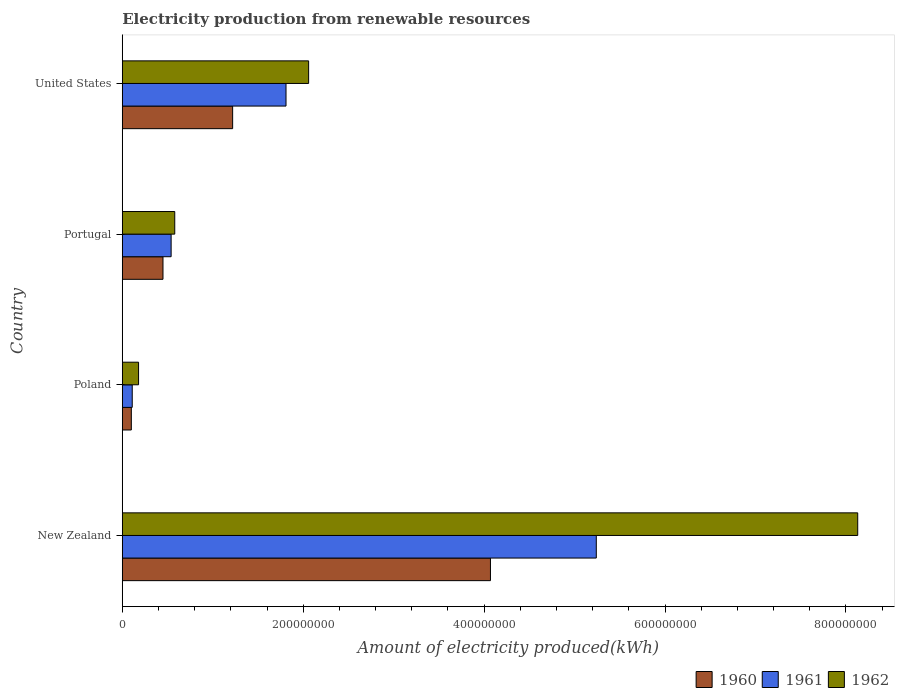How many different coloured bars are there?
Ensure brevity in your answer.  3. What is the label of the 4th group of bars from the top?
Make the answer very short. New Zealand. In how many cases, is the number of bars for a given country not equal to the number of legend labels?
Give a very brief answer. 0. What is the amount of electricity produced in 1961 in Poland?
Offer a very short reply. 1.10e+07. Across all countries, what is the maximum amount of electricity produced in 1960?
Make the answer very short. 4.07e+08. In which country was the amount of electricity produced in 1962 maximum?
Keep it short and to the point. New Zealand. In which country was the amount of electricity produced in 1961 minimum?
Give a very brief answer. Poland. What is the total amount of electricity produced in 1962 in the graph?
Your answer should be compact. 1.10e+09. What is the difference between the amount of electricity produced in 1961 in Portugal and that in United States?
Ensure brevity in your answer.  -1.27e+08. What is the difference between the amount of electricity produced in 1962 in New Zealand and the amount of electricity produced in 1960 in United States?
Make the answer very short. 6.91e+08. What is the average amount of electricity produced in 1960 per country?
Provide a succinct answer. 1.46e+08. What is the difference between the amount of electricity produced in 1961 and amount of electricity produced in 1960 in New Zealand?
Provide a succinct answer. 1.17e+08. What is the ratio of the amount of electricity produced in 1961 in New Zealand to that in Portugal?
Offer a terse response. 9.7. Is the amount of electricity produced in 1962 in Poland less than that in United States?
Your response must be concise. Yes. What is the difference between the highest and the second highest amount of electricity produced in 1962?
Make the answer very short. 6.07e+08. What is the difference between the highest and the lowest amount of electricity produced in 1960?
Make the answer very short. 3.97e+08. Is the sum of the amount of electricity produced in 1962 in Portugal and United States greater than the maximum amount of electricity produced in 1961 across all countries?
Your answer should be very brief. No. What does the 3rd bar from the top in Portugal represents?
Make the answer very short. 1960. Is it the case that in every country, the sum of the amount of electricity produced in 1960 and amount of electricity produced in 1962 is greater than the amount of electricity produced in 1961?
Your response must be concise. Yes. Are all the bars in the graph horizontal?
Keep it short and to the point. Yes. What is the difference between two consecutive major ticks on the X-axis?
Make the answer very short. 2.00e+08. Does the graph contain any zero values?
Offer a terse response. No. How many legend labels are there?
Ensure brevity in your answer.  3. How are the legend labels stacked?
Your response must be concise. Horizontal. What is the title of the graph?
Provide a short and direct response. Electricity production from renewable resources. What is the label or title of the X-axis?
Ensure brevity in your answer.  Amount of electricity produced(kWh). What is the label or title of the Y-axis?
Ensure brevity in your answer.  Country. What is the Amount of electricity produced(kWh) of 1960 in New Zealand?
Ensure brevity in your answer.  4.07e+08. What is the Amount of electricity produced(kWh) of 1961 in New Zealand?
Your response must be concise. 5.24e+08. What is the Amount of electricity produced(kWh) in 1962 in New Zealand?
Provide a short and direct response. 8.13e+08. What is the Amount of electricity produced(kWh) of 1961 in Poland?
Provide a succinct answer. 1.10e+07. What is the Amount of electricity produced(kWh) in 1962 in Poland?
Your response must be concise. 1.80e+07. What is the Amount of electricity produced(kWh) in 1960 in Portugal?
Ensure brevity in your answer.  4.50e+07. What is the Amount of electricity produced(kWh) of 1961 in Portugal?
Offer a terse response. 5.40e+07. What is the Amount of electricity produced(kWh) in 1962 in Portugal?
Your answer should be compact. 5.80e+07. What is the Amount of electricity produced(kWh) in 1960 in United States?
Make the answer very short. 1.22e+08. What is the Amount of electricity produced(kWh) in 1961 in United States?
Offer a terse response. 1.81e+08. What is the Amount of electricity produced(kWh) in 1962 in United States?
Offer a terse response. 2.06e+08. Across all countries, what is the maximum Amount of electricity produced(kWh) of 1960?
Your answer should be very brief. 4.07e+08. Across all countries, what is the maximum Amount of electricity produced(kWh) of 1961?
Provide a short and direct response. 5.24e+08. Across all countries, what is the maximum Amount of electricity produced(kWh) in 1962?
Provide a succinct answer. 8.13e+08. Across all countries, what is the minimum Amount of electricity produced(kWh) of 1960?
Offer a very short reply. 1.00e+07. Across all countries, what is the minimum Amount of electricity produced(kWh) of 1961?
Your response must be concise. 1.10e+07. Across all countries, what is the minimum Amount of electricity produced(kWh) in 1962?
Your response must be concise. 1.80e+07. What is the total Amount of electricity produced(kWh) of 1960 in the graph?
Your answer should be compact. 5.84e+08. What is the total Amount of electricity produced(kWh) of 1961 in the graph?
Keep it short and to the point. 7.70e+08. What is the total Amount of electricity produced(kWh) in 1962 in the graph?
Give a very brief answer. 1.10e+09. What is the difference between the Amount of electricity produced(kWh) in 1960 in New Zealand and that in Poland?
Offer a very short reply. 3.97e+08. What is the difference between the Amount of electricity produced(kWh) in 1961 in New Zealand and that in Poland?
Your answer should be compact. 5.13e+08. What is the difference between the Amount of electricity produced(kWh) in 1962 in New Zealand and that in Poland?
Your answer should be very brief. 7.95e+08. What is the difference between the Amount of electricity produced(kWh) of 1960 in New Zealand and that in Portugal?
Your response must be concise. 3.62e+08. What is the difference between the Amount of electricity produced(kWh) of 1961 in New Zealand and that in Portugal?
Keep it short and to the point. 4.70e+08. What is the difference between the Amount of electricity produced(kWh) in 1962 in New Zealand and that in Portugal?
Provide a succinct answer. 7.55e+08. What is the difference between the Amount of electricity produced(kWh) of 1960 in New Zealand and that in United States?
Ensure brevity in your answer.  2.85e+08. What is the difference between the Amount of electricity produced(kWh) in 1961 in New Zealand and that in United States?
Offer a very short reply. 3.43e+08. What is the difference between the Amount of electricity produced(kWh) of 1962 in New Zealand and that in United States?
Make the answer very short. 6.07e+08. What is the difference between the Amount of electricity produced(kWh) of 1960 in Poland and that in Portugal?
Ensure brevity in your answer.  -3.50e+07. What is the difference between the Amount of electricity produced(kWh) of 1961 in Poland and that in Portugal?
Provide a short and direct response. -4.30e+07. What is the difference between the Amount of electricity produced(kWh) of 1962 in Poland and that in Portugal?
Offer a terse response. -4.00e+07. What is the difference between the Amount of electricity produced(kWh) in 1960 in Poland and that in United States?
Keep it short and to the point. -1.12e+08. What is the difference between the Amount of electricity produced(kWh) in 1961 in Poland and that in United States?
Offer a terse response. -1.70e+08. What is the difference between the Amount of electricity produced(kWh) in 1962 in Poland and that in United States?
Your answer should be very brief. -1.88e+08. What is the difference between the Amount of electricity produced(kWh) of 1960 in Portugal and that in United States?
Provide a short and direct response. -7.70e+07. What is the difference between the Amount of electricity produced(kWh) in 1961 in Portugal and that in United States?
Make the answer very short. -1.27e+08. What is the difference between the Amount of electricity produced(kWh) of 1962 in Portugal and that in United States?
Keep it short and to the point. -1.48e+08. What is the difference between the Amount of electricity produced(kWh) in 1960 in New Zealand and the Amount of electricity produced(kWh) in 1961 in Poland?
Your answer should be very brief. 3.96e+08. What is the difference between the Amount of electricity produced(kWh) of 1960 in New Zealand and the Amount of electricity produced(kWh) of 1962 in Poland?
Offer a terse response. 3.89e+08. What is the difference between the Amount of electricity produced(kWh) in 1961 in New Zealand and the Amount of electricity produced(kWh) in 1962 in Poland?
Give a very brief answer. 5.06e+08. What is the difference between the Amount of electricity produced(kWh) of 1960 in New Zealand and the Amount of electricity produced(kWh) of 1961 in Portugal?
Provide a short and direct response. 3.53e+08. What is the difference between the Amount of electricity produced(kWh) of 1960 in New Zealand and the Amount of electricity produced(kWh) of 1962 in Portugal?
Your answer should be compact. 3.49e+08. What is the difference between the Amount of electricity produced(kWh) of 1961 in New Zealand and the Amount of electricity produced(kWh) of 1962 in Portugal?
Offer a very short reply. 4.66e+08. What is the difference between the Amount of electricity produced(kWh) of 1960 in New Zealand and the Amount of electricity produced(kWh) of 1961 in United States?
Keep it short and to the point. 2.26e+08. What is the difference between the Amount of electricity produced(kWh) in 1960 in New Zealand and the Amount of electricity produced(kWh) in 1962 in United States?
Keep it short and to the point. 2.01e+08. What is the difference between the Amount of electricity produced(kWh) in 1961 in New Zealand and the Amount of electricity produced(kWh) in 1962 in United States?
Keep it short and to the point. 3.18e+08. What is the difference between the Amount of electricity produced(kWh) of 1960 in Poland and the Amount of electricity produced(kWh) of 1961 in Portugal?
Make the answer very short. -4.40e+07. What is the difference between the Amount of electricity produced(kWh) of 1960 in Poland and the Amount of electricity produced(kWh) of 1962 in Portugal?
Offer a very short reply. -4.80e+07. What is the difference between the Amount of electricity produced(kWh) in 1961 in Poland and the Amount of electricity produced(kWh) in 1962 in Portugal?
Give a very brief answer. -4.70e+07. What is the difference between the Amount of electricity produced(kWh) in 1960 in Poland and the Amount of electricity produced(kWh) in 1961 in United States?
Your answer should be very brief. -1.71e+08. What is the difference between the Amount of electricity produced(kWh) of 1960 in Poland and the Amount of electricity produced(kWh) of 1962 in United States?
Offer a very short reply. -1.96e+08. What is the difference between the Amount of electricity produced(kWh) in 1961 in Poland and the Amount of electricity produced(kWh) in 1962 in United States?
Your answer should be compact. -1.95e+08. What is the difference between the Amount of electricity produced(kWh) of 1960 in Portugal and the Amount of electricity produced(kWh) of 1961 in United States?
Provide a succinct answer. -1.36e+08. What is the difference between the Amount of electricity produced(kWh) of 1960 in Portugal and the Amount of electricity produced(kWh) of 1962 in United States?
Provide a succinct answer. -1.61e+08. What is the difference between the Amount of electricity produced(kWh) of 1961 in Portugal and the Amount of electricity produced(kWh) of 1962 in United States?
Make the answer very short. -1.52e+08. What is the average Amount of electricity produced(kWh) of 1960 per country?
Provide a short and direct response. 1.46e+08. What is the average Amount of electricity produced(kWh) in 1961 per country?
Keep it short and to the point. 1.92e+08. What is the average Amount of electricity produced(kWh) of 1962 per country?
Make the answer very short. 2.74e+08. What is the difference between the Amount of electricity produced(kWh) in 1960 and Amount of electricity produced(kWh) in 1961 in New Zealand?
Make the answer very short. -1.17e+08. What is the difference between the Amount of electricity produced(kWh) in 1960 and Amount of electricity produced(kWh) in 1962 in New Zealand?
Keep it short and to the point. -4.06e+08. What is the difference between the Amount of electricity produced(kWh) in 1961 and Amount of electricity produced(kWh) in 1962 in New Zealand?
Keep it short and to the point. -2.89e+08. What is the difference between the Amount of electricity produced(kWh) of 1960 and Amount of electricity produced(kWh) of 1962 in Poland?
Provide a short and direct response. -8.00e+06. What is the difference between the Amount of electricity produced(kWh) of 1961 and Amount of electricity produced(kWh) of 1962 in Poland?
Give a very brief answer. -7.00e+06. What is the difference between the Amount of electricity produced(kWh) in 1960 and Amount of electricity produced(kWh) in 1961 in Portugal?
Keep it short and to the point. -9.00e+06. What is the difference between the Amount of electricity produced(kWh) in 1960 and Amount of electricity produced(kWh) in 1962 in Portugal?
Provide a short and direct response. -1.30e+07. What is the difference between the Amount of electricity produced(kWh) of 1960 and Amount of electricity produced(kWh) of 1961 in United States?
Offer a very short reply. -5.90e+07. What is the difference between the Amount of electricity produced(kWh) of 1960 and Amount of electricity produced(kWh) of 1962 in United States?
Offer a very short reply. -8.40e+07. What is the difference between the Amount of electricity produced(kWh) in 1961 and Amount of electricity produced(kWh) in 1962 in United States?
Your response must be concise. -2.50e+07. What is the ratio of the Amount of electricity produced(kWh) of 1960 in New Zealand to that in Poland?
Your answer should be very brief. 40.7. What is the ratio of the Amount of electricity produced(kWh) of 1961 in New Zealand to that in Poland?
Provide a short and direct response. 47.64. What is the ratio of the Amount of electricity produced(kWh) in 1962 in New Zealand to that in Poland?
Provide a short and direct response. 45.17. What is the ratio of the Amount of electricity produced(kWh) in 1960 in New Zealand to that in Portugal?
Your answer should be compact. 9.04. What is the ratio of the Amount of electricity produced(kWh) of 1961 in New Zealand to that in Portugal?
Offer a very short reply. 9.7. What is the ratio of the Amount of electricity produced(kWh) of 1962 in New Zealand to that in Portugal?
Give a very brief answer. 14.02. What is the ratio of the Amount of electricity produced(kWh) of 1960 in New Zealand to that in United States?
Your response must be concise. 3.34. What is the ratio of the Amount of electricity produced(kWh) of 1961 in New Zealand to that in United States?
Provide a succinct answer. 2.9. What is the ratio of the Amount of electricity produced(kWh) in 1962 in New Zealand to that in United States?
Offer a terse response. 3.95. What is the ratio of the Amount of electricity produced(kWh) of 1960 in Poland to that in Portugal?
Make the answer very short. 0.22. What is the ratio of the Amount of electricity produced(kWh) in 1961 in Poland to that in Portugal?
Your response must be concise. 0.2. What is the ratio of the Amount of electricity produced(kWh) in 1962 in Poland to that in Portugal?
Ensure brevity in your answer.  0.31. What is the ratio of the Amount of electricity produced(kWh) in 1960 in Poland to that in United States?
Make the answer very short. 0.08. What is the ratio of the Amount of electricity produced(kWh) in 1961 in Poland to that in United States?
Your response must be concise. 0.06. What is the ratio of the Amount of electricity produced(kWh) of 1962 in Poland to that in United States?
Offer a very short reply. 0.09. What is the ratio of the Amount of electricity produced(kWh) of 1960 in Portugal to that in United States?
Ensure brevity in your answer.  0.37. What is the ratio of the Amount of electricity produced(kWh) in 1961 in Portugal to that in United States?
Make the answer very short. 0.3. What is the ratio of the Amount of electricity produced(kWh) in 1962 in Portugal to that in United States?
Your answer should be very brief. 0.28. What is the difference between the highest and the second highest Amount of electricity produced(kWh) of 1960?
Keep it short and to the point. 2.85e+08. What is the difference between the highest and the second highest Amount of electricity produced(kWh) of 1961?
Keep it short and to the point. 3.43e+08. What is the difference between the highest and the second highest Amount of electricity produced(kWh) of 1962?
Give a very brief answer. 6.07e+08. What is the difference between the highest and the lowest Amount of electricity produced(kWh) in 1960?
Your response must be concise. 3.97e+08. What is the difference between the highest and the lowest Amount of electricity produced(kWh) in 1961?
Offer a very short reply. 5.13e+08. What is the difference between the highest and the lowest Amount of electricity produced(kWh) in 1962?
Provide a short and direct response. 7.95e+08. 